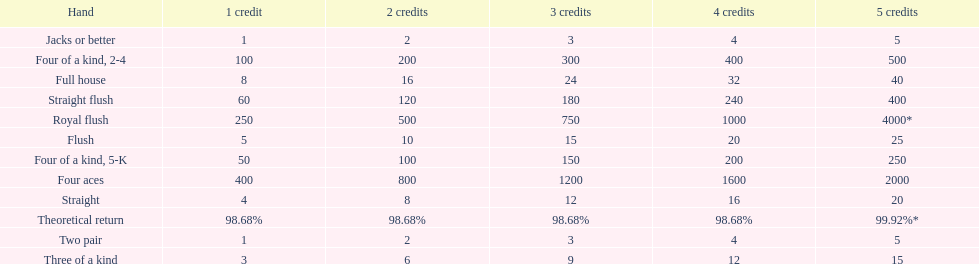Each four aces win is a multiple of what number? 400. 